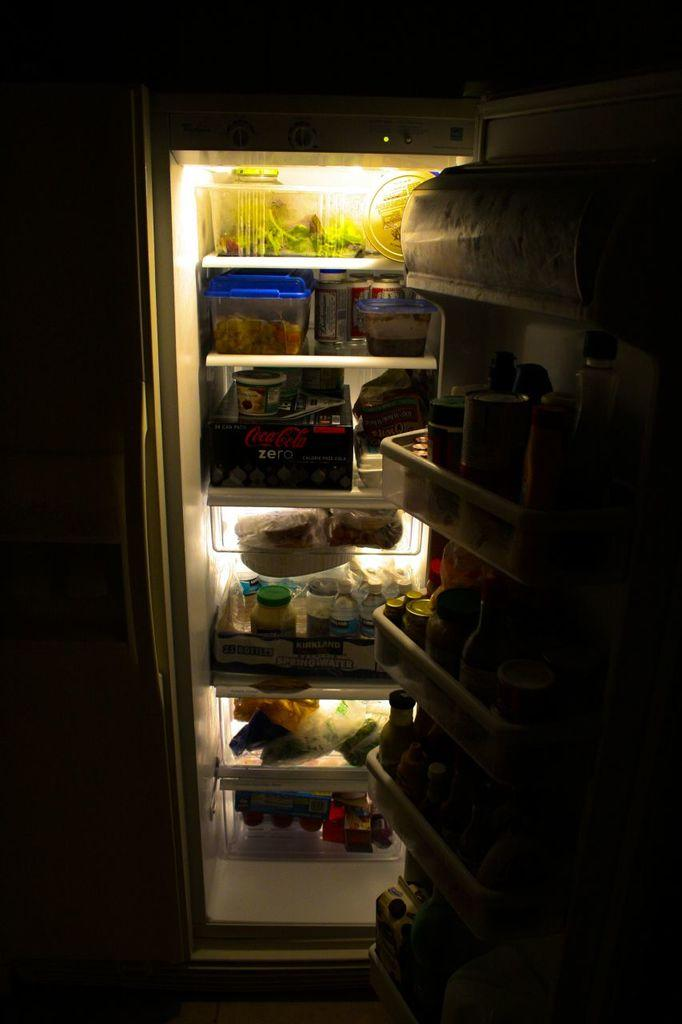Provide a one-sentence caption for the provided image. the inside of a dark fridge, with a pack of coke zero on the third shelf. 